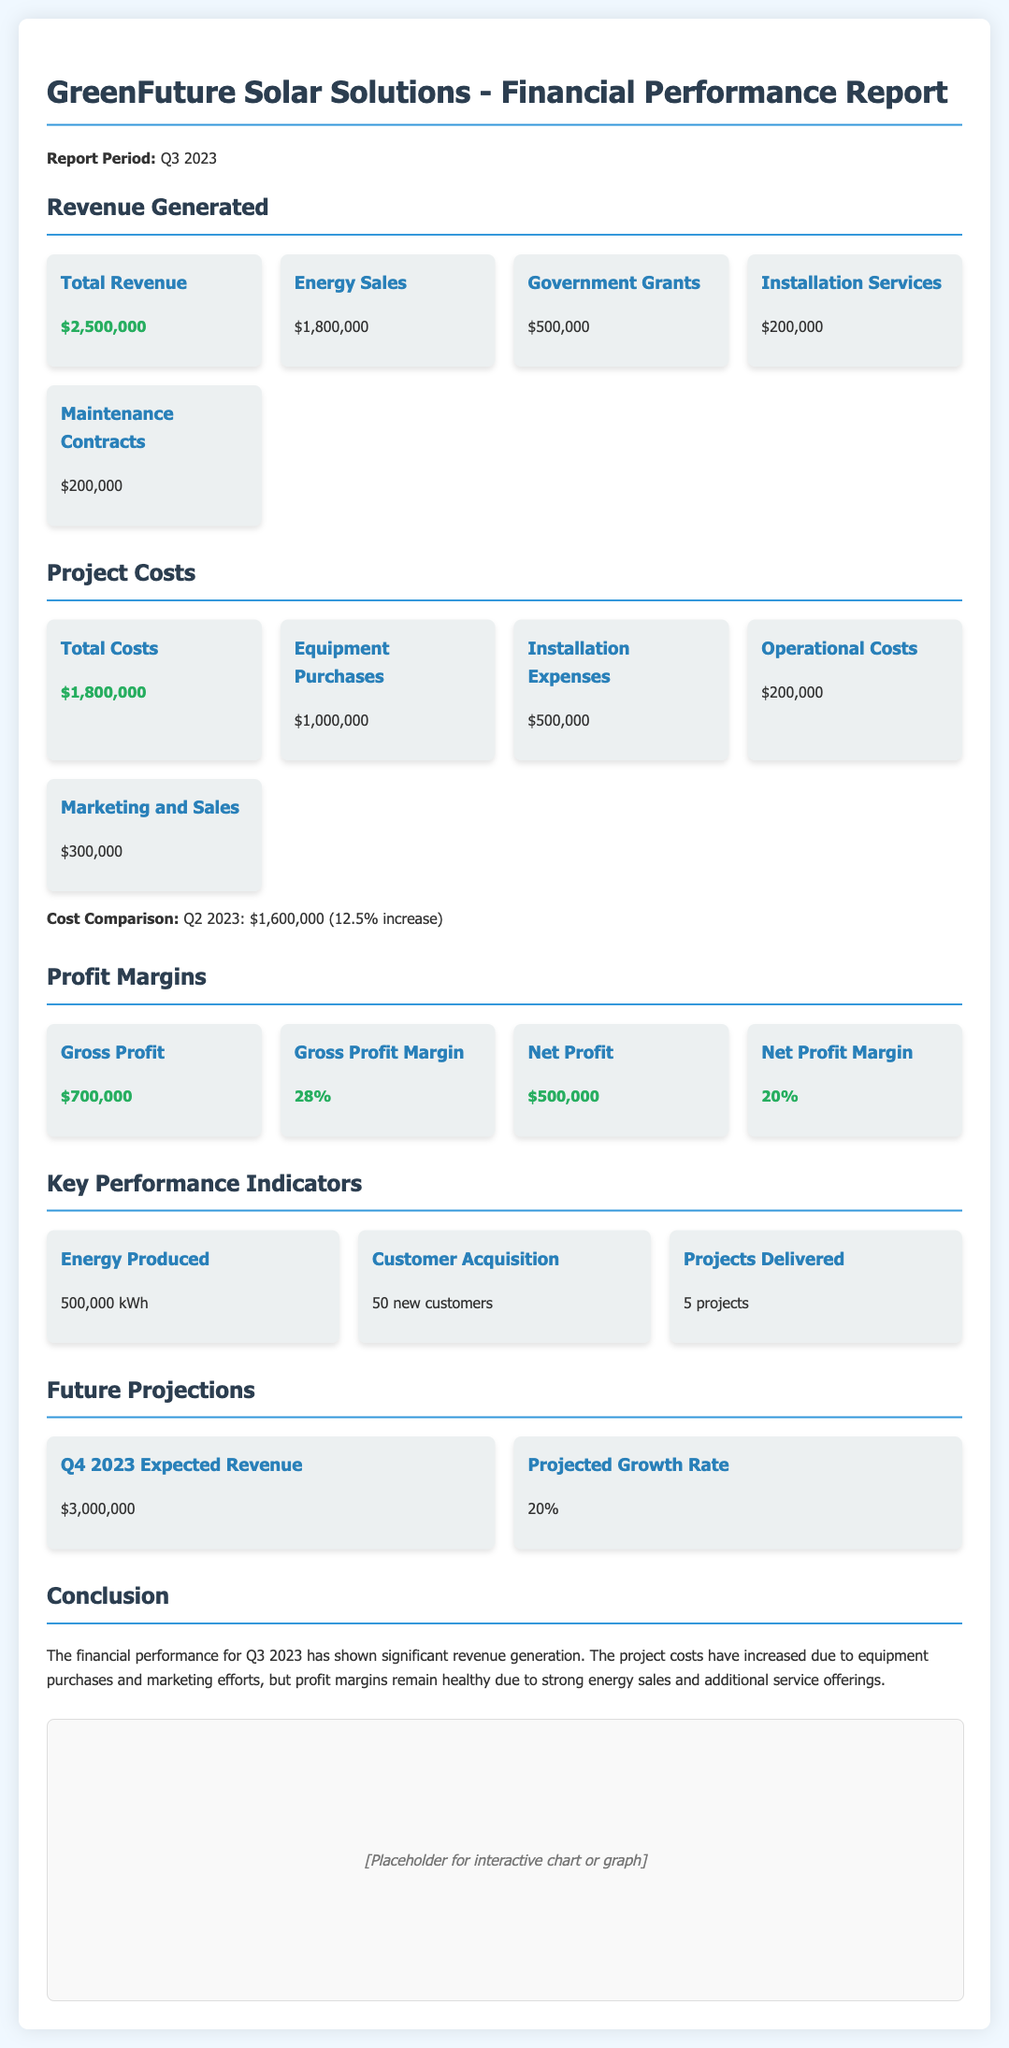What is the total revenue? The total revenue is listed as $2,500,000 in the document.
Answer: $2,500,000 What are installation services revenue? The revenue from installation services is specified as $200,000.
Answer: $200,000 What is the gross profit margin? The document shows that the gross profit margin is 28%.
Answer: 28% What was the total cost? Total costs for the project is mentioned as $1,800,000.
Answer: $1,800,000 How many new customers were acquired? The document states that 50 new customers were acquired during this period.
Answer: 50 What is the net profit? The net profit reported in the document is $500,000.
Answer: $500,000 What was the projected growth rate for Q4 2023? The expected growth rate for the next quarter is illustrated as 20%.
Answer: 20% What was the energy production in kWh? The document indicates that 500,000 kWh of energy were produced.
Answer: 500,000 kWh What was the increase in project costs compared to Q2 2023? The cost comparison notes a 12.5% increase in project costs from Q2 2023.
Answer: 12.5% 